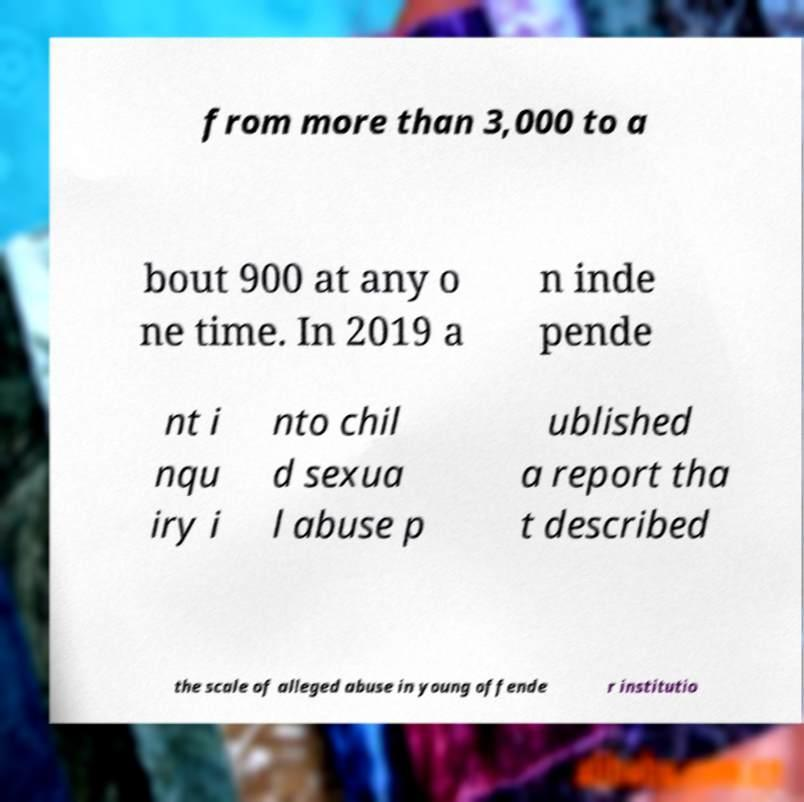What messages or text are displayed in this image? I need them in a readable, typed format. from more than 3,000 to a bout 900 at any o ne time. In 2019 a n inde pende nt i nqu iry i nto chil d sexua l abuse p ublished a report tha t described the scale of alleged abuse in young offende r institutio 